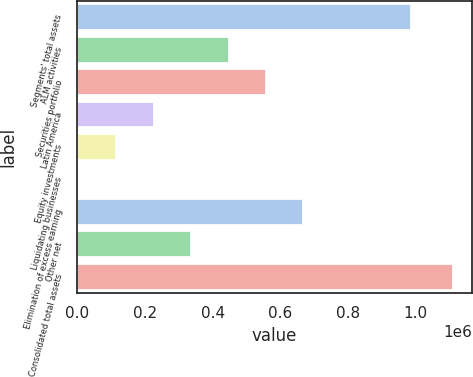Convert chart. <chart><loc_0><loc_0><loc_500><loc_500><bar_chart><fcel>Segments' total assets<fcel>ALM activities<fcel>Securities portfolio<fcel>Latin America<fcel>Equity investments<fcel>Liquidating businesses<fcel>Elimination of excess earning<fcel>Other net<fcel>Consolidated total assets<nl><fcel>985877<fcel>446817<fcel>557424<fcel>225603<fcel>114997<fcel>4390<fcel>668030<fcel>336210<fcel>1.11046e+06<nl></chart> 